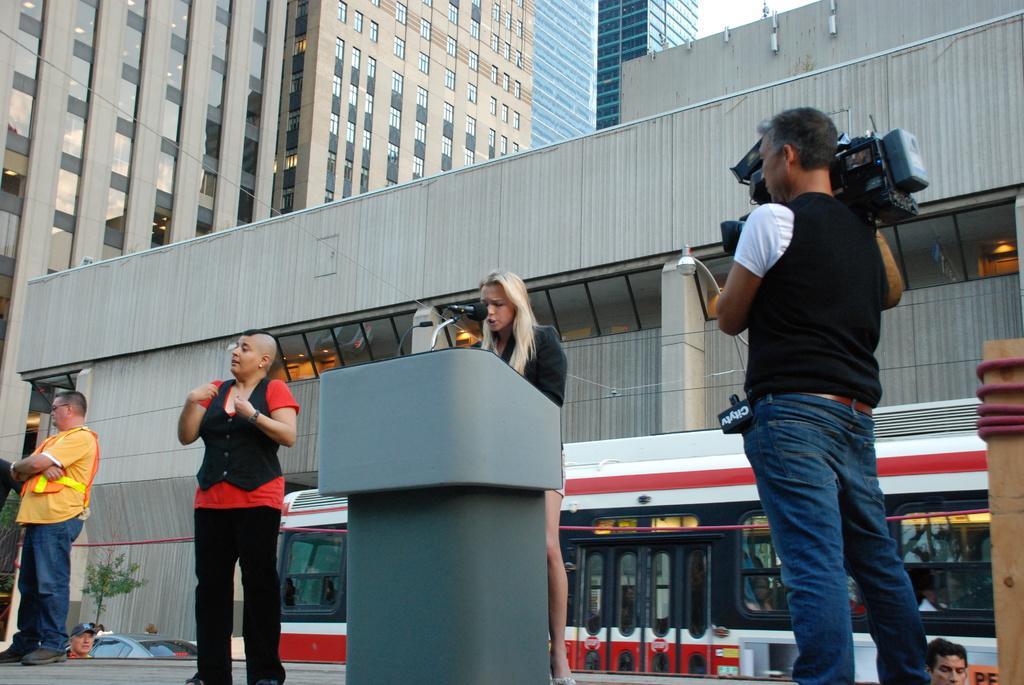In one or two sentences, can you explain what this image depicts? In this picture I can see there are few people standing a man on to left and a man on to right holding a camera and there are two women here, one of them is standing here behind the wooden table and the other is standing. In the backdrop there are few people walking, few vehicles moving and there are buildings and the sky is clear. 